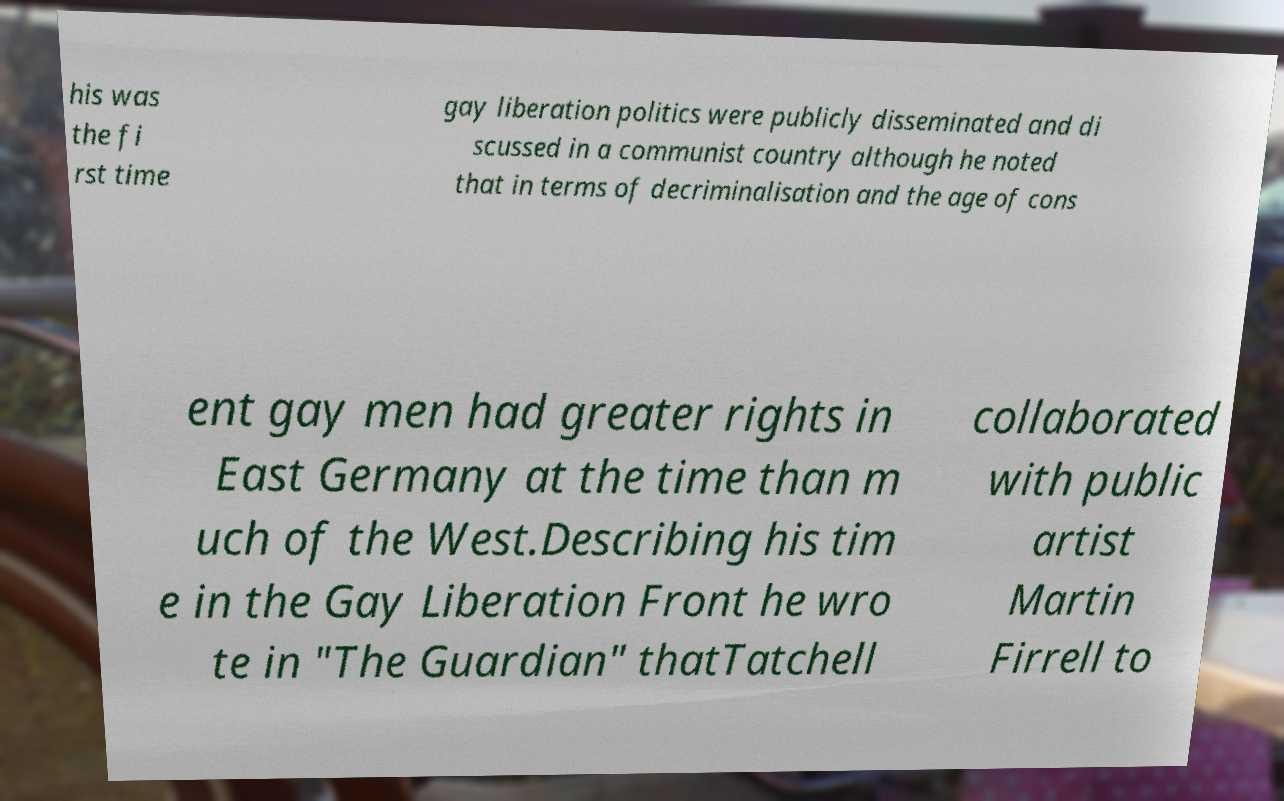What messages or text are displayed in this image? I need them in a readable, typed format. his was the fi rst time gay liberation politics were publicly disseminated and di scussed in a communist country although he noted that in terms of decriminalisation and the age of cons ent gay men had greater rights in East Germany at the time than m uch of the West.Describing his tim e in the Gay Liberation Front he wro te in "The Guardian" thatTatchell collaborated with public artist Martin Firrell to 